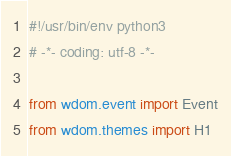<code> <loc_0><loc_0><loc_500><loc_500><_Python_>#!/usr/bin/env python3
# -*- coding: utf-8 -*-

from wdom.event import Event
from wdom.themes import H1

</code> 